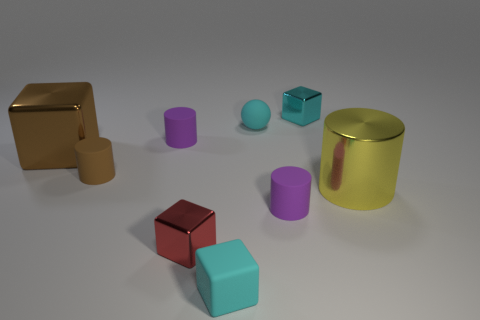What shape is the metal thing that is the same color as the matte cube?
Your response must be concise. Cube. How many other things are there of the same shape as the big yellow shiny object?
Ensure brevity in your answer.  3. What shape is the large yellow object?
Offer a very short reply. Cylinder. Is the small brown object made of the same material as the large yellow object?
Offer a very short reply. No. Is the number of cyan metallic objects that are to the right of the large shiny cylinder the same as the number of big metallic blocks that are in front of the tiny brown cylinder?
Your answer should be very brief. Yes. Is there a big brown metallic cube that is behind the tiny cube in front of the metallic thing in front of the large yellow object?
Ensure brevity in your answer.  Yes. Is the cyan metal thing the same size as the red thing?
Offer a terse response. Yes. What is the color of the tiny shiny block that is to the left of the tiny cyan cube in front of the large yellow thing that is in front of the matte sphere?
Provide a succinct answer. Red. What number of tiny things have the same color as the tiny matte ball?
Provide a short and direct response. 2. What number of small objects are blocks or purple cylinders?
Offer a very short reply. 5. 